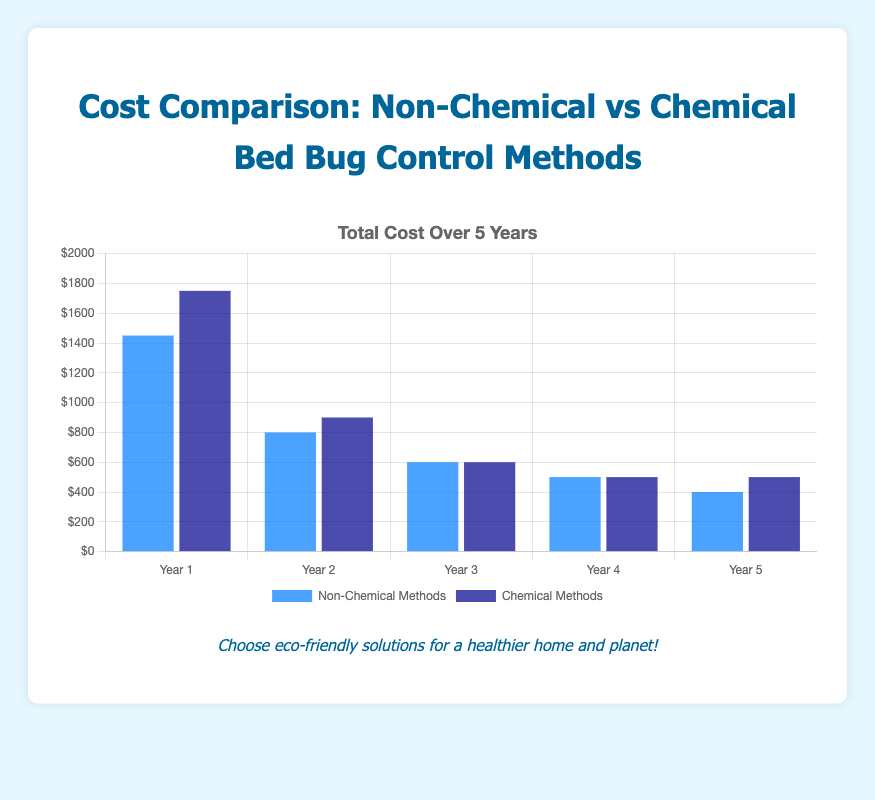What's the total cost of Non-Chemical Methods in Year 1 and Year 2 combined? To find the total cost, sum the values for Non-Chemical Methods in Year 1 and Year 2. In Year 1, the cost is $1450. In Year 2, the cost is $800. The combined total is $1450 + $800 = $2250.
Answer: $2250 How does the cost of Chemical Methods in Year 5 compare to that in Year 4? In Year 4, the cost of Chemical Methods is $500. In Year 5, the cost remains $500. Since both values are equal, the cost does not change between Year 4 and Year 5.
Answer: No change / Equal Which method (Non-Chemical or Chemical) had a higher total cost in Year 3? In Year 3, the total cost for Non-Chemical Methods is $600. The total cost for Chemical Methods is also $600. Comparing these, we find they are equal.
Answer: Equal In which year was the difference between Non-Chemical and Chemical Methods' costs the greatest? To find the year with the greatest difference, calculate the absolute differences for each year. Year 1: $1750 - $1450 = $300, Year 2: $900 - $800 = $100, Year 3: $600 - $600 = $0, Year 4: $500 - $500 = $0, Year 5: $500 - $400 = $100. The greatest difference is in Year 1 at $300.
Answer: Year 1 What's the average cost of Non-Chemical Methods over the 5-year period? To find the average cost, sum up the total costs for Non-Chemical Methods over 5 years and divide by 5. The total cost is $1450 + $800 + $600 + $500 + $400 = $3750. Therefore, the average is $3750 / 5 = $750.
Answer: $750 What is the combined cost of 'Heat Treatment' and 'Cold Treatment' in Year 3? In Year 3, the cost for 'Heat Treatment' is $150, and for 'Cold Treatment' is $200. Summing these gives $150 + $200 = $350.
Answer: $350 By Year 5, which non-chemical method had the lowest cost, and what was that cost? By Year 5, "Diatomaceous Earth" had the lowest cost among non-chemical methods. Its cost was $50.
Answer: Diatomaceous Earth, $50 Which treatment method had the highest initial cost in Year 1, and what was it? In Year 1, "Fumigation" had the highest initial cost among all methods. Its cost was $1000.
Answer: Fumigation, $1000 